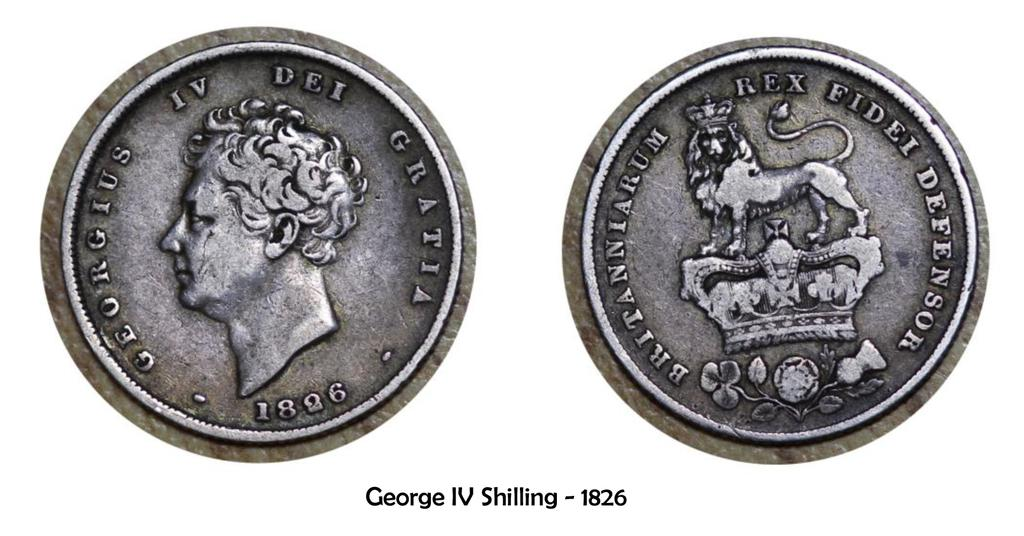<image>
Create a compact narrative representing the image presented. A silver coin from 1826 that says Rex Fidei Defensor. 